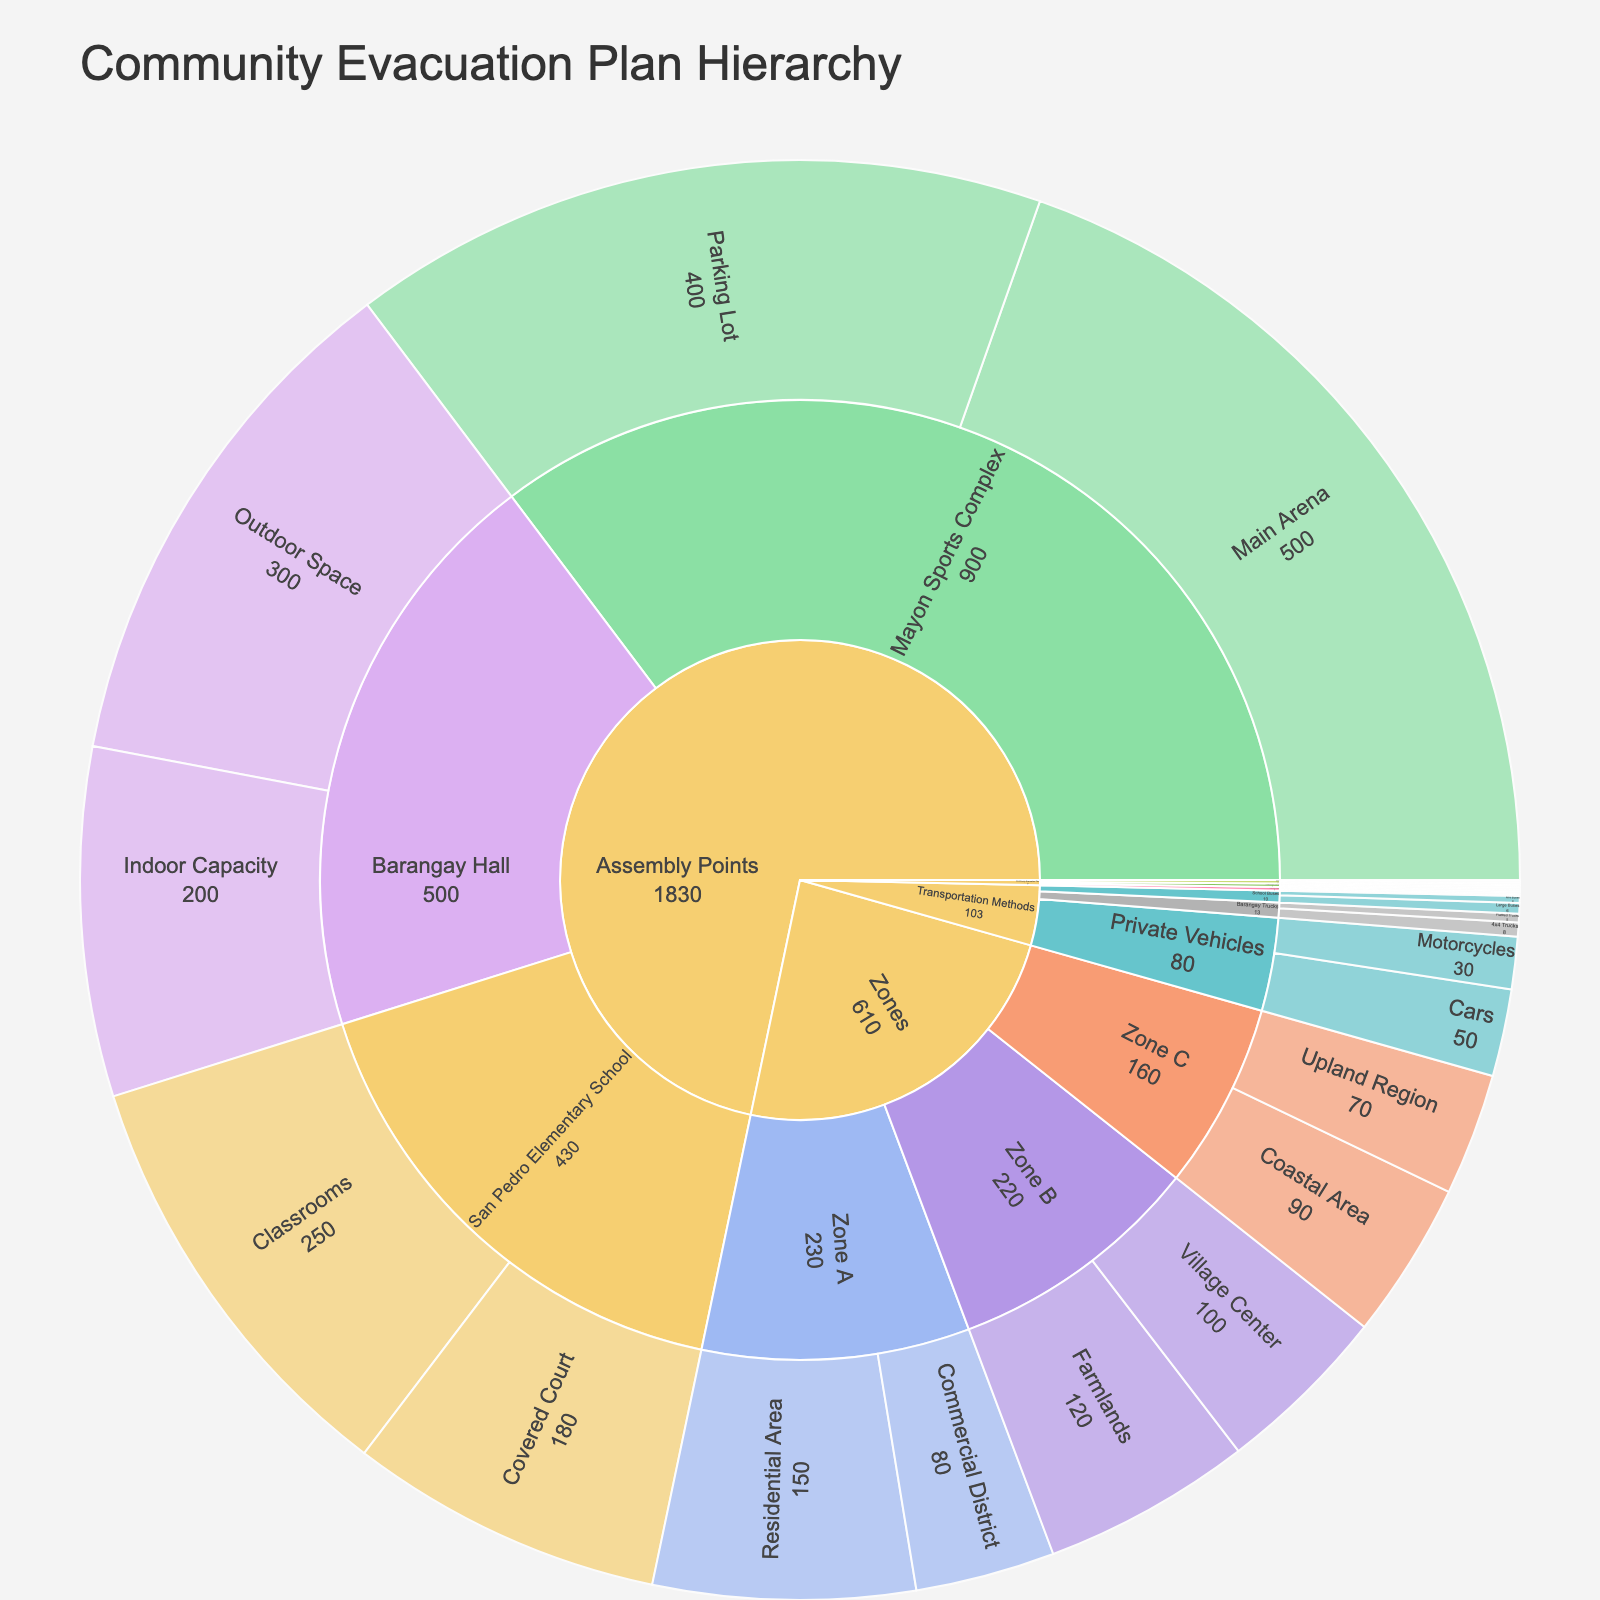what is the title of the plot? The title is located at the top of the plot in large font, displaying the main topic of the visual.
Answer: Community Evacuation Plan Hierarchy How many 4x4 trucks are there in Barangay Trucks? Find the section labeled "Transportation Methods" and follow the branches to "Barangay Trucks" and then "4x4 Trucks". Count the number presented.
Answer: 8 What is the indoor capacity of Barangay Hall as an assembly point? Locate the section labeled "Assembly Points" and follow to "Barangay Hall". Identify the "Indoor Capacity" subtree and note the value.
Answer: 200 What zone covers the coastal area and what is its population? Navigate to the "Zones" category and follow to "Zone C". Find "Coastal Area" and read the associated value.
Answer: Zone C, 90 How many more large buses are there compared to mini buses under School Buses? Locate the "Transportation Methods" category, then "School Buses". Compare the counts of "Large Buses" and "Mini Buses" and subtract the mini buses from the large buses: 6 (large) - 4 (mini).
Answer: 2 What is the sum of the values for the Residential Area and Commercial District in Zone A? Locate "Zones", then "Zone A". Identify "Residential Area" and "Commercial District" values and add them: 150 (Residential) + 80 (Commercial).
Answer: 230 Which assembly point has the highest capacity and what is it? Within "Assembly Points", compare the capacities of all subcategories and find the highest value: "Barangay Hall" (200 + 300), "San Pedro Elementary School" (250 + 180), "Mayon Sports Complex" (500 + 400).
Answer: Mayon Sports Complex, 900 How does the number of cars compare to motorcycles in private vehicles? Extract values from the "Private Vehicles" branch under "Transportation Methods" and compare "Cars" (50) to "Motorcycles" (30).
Answer: There are 20 more cars than motorcycles What is the total population covered by Zone B? Locate "Zone B" and add up the values of "Farmlands" and "Village Center": 120 + 100.
Answer: 220 Which category has the most number of subcategories/branches? Compare the number of subbranches under "Zones", "Assembly Points", and "Transportation Methods".
Answer: Transportation Methods 